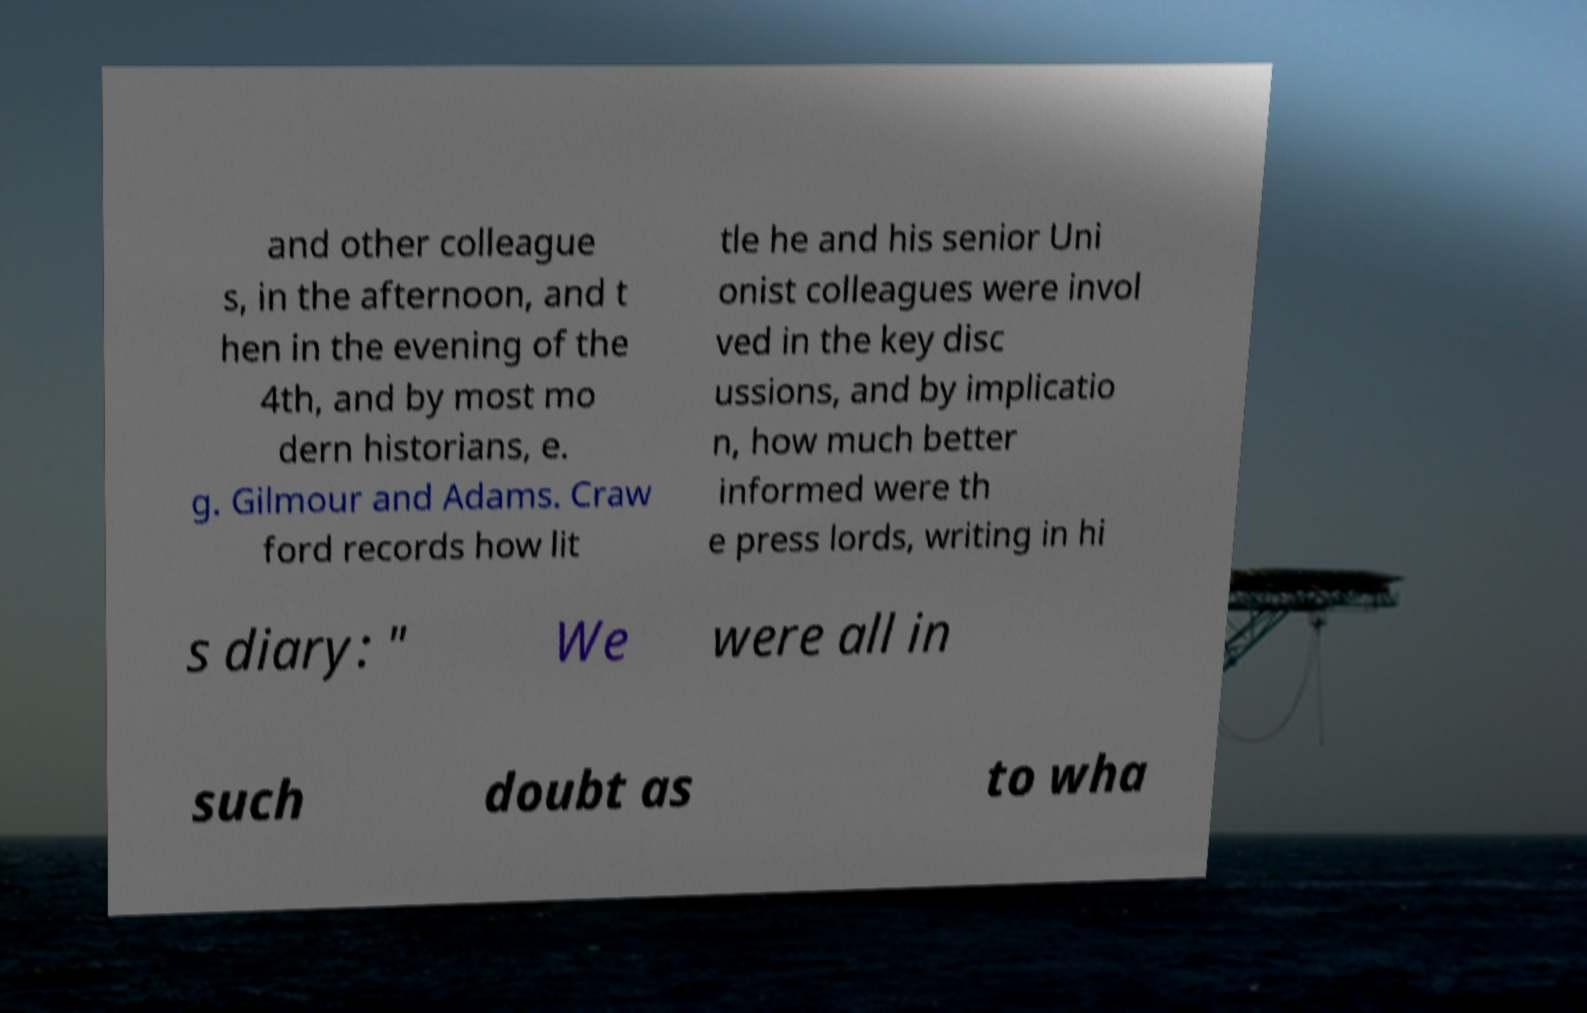Can you read and provide the text displayed in the image?This photo seems to have some interesting text. Can you extract and type it out for me? and other colleague s, in the afternoon, and t hen in the evening of the 4th, and by most mo dern historians, e. g. Gilmour and Adams. Craw ford records how lit tle he and his senior Uni onist colleagues were invol ved in the key disc ussions, and by implicatio n, how much better informed were th e press lords, writing in hi s diary: " We were all in such doubt as to wha 